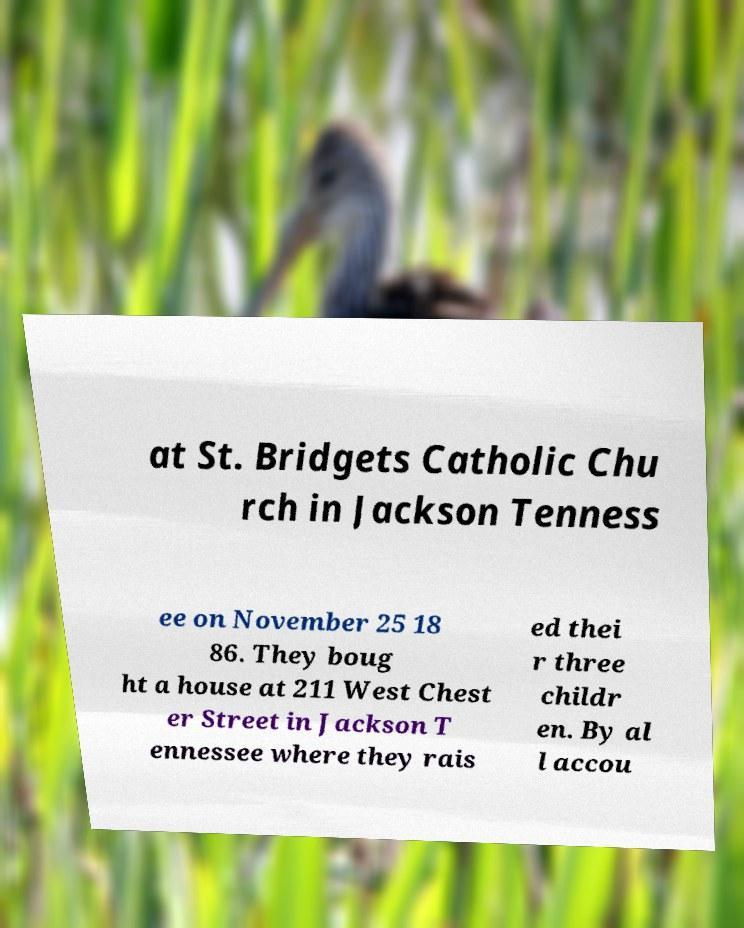Please read and relay the text visible in this image. What does it say? at St. Bridgets Catholic Chu rch in Jackson Tenness ee on November 25 18 86. They boug ht a house at 211 West Chest er Street in Jackson T ennessee where they rais ed thei r three childr en. By al l accou 